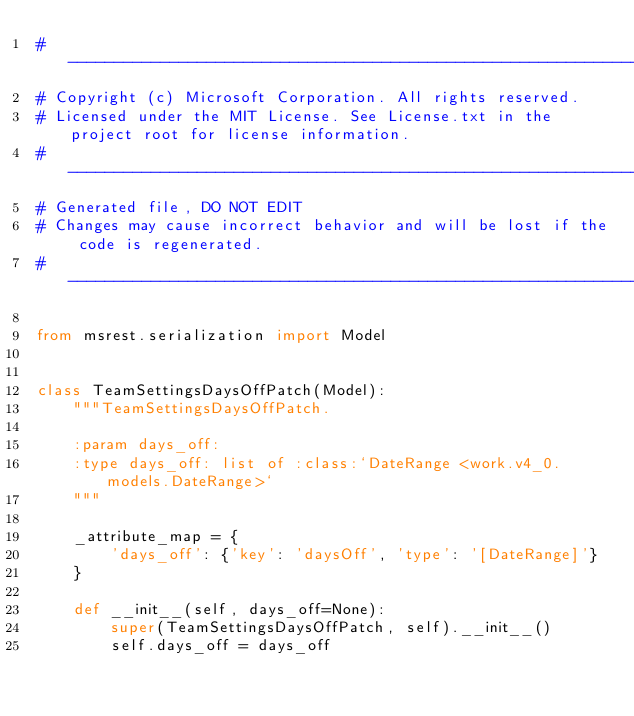Convert code to text. <code><loc_0><loc_0><loc_500><loc_500><_Python_># --------------------------------------------------------------------------------------------
# Copyright (c) Microsoft Corporation. All rights reserved.
# Licensed under the MIT License. See License.txt in the project root for license information.
# --------------------------------------------------------------------------------------------
# Generated file, DO NOT EDIT
# Changes may cause incorrect behavior and will be lost if the code is regenerated.
# --------------------------------------------------------------------------------------------

from msrest.serialization import Model


class TeamSettingsDaysOffPatch(Model):
    """TeamSettingsDaysOffPatch.

    :param days_off:
    :type days_off: list of :class:`DateRange <work.v4_0.models.DateRange>`
    """

    _attribute_map = {
        'days_off': {'key': 'daysOff', 'type': '[DateRange]'}
    }

    def __init__(self, days_off=None):
        super(TeamSettingsDaysOffPatch, self).__init__()
        self.days_off = days_off
</code> 